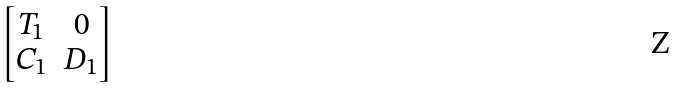Convert formula to latex. <formula><loc_0><loc_0><loc_500><loc_500>\begin{bmatrix} T _ { 1 } & 0 \\ C _ { 1 } & D _ { 1 } \\ \end{bmatrix}</formula> 